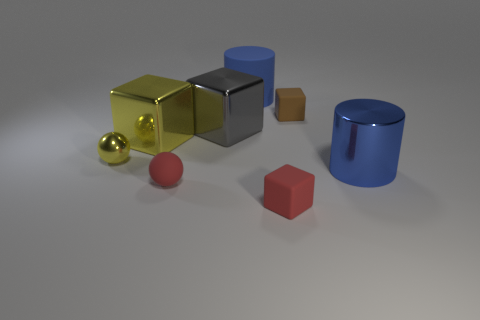Does the large cylinder in front of the small brown cube have the same material as the large blue thing that is behind the tiny brown object?
Your response must be concise. No. There is a gray thing that is to the left of the red cube; is its size the same as the rubber cylinder?
Your answer should be very brief. Yes. Do the rubber ball and the small rubber cube in front of the yellow sphere have the same color?
Your answer should be very brief. Yes. There is a metal thing that is the same color as the tiny metal ball; what shape is it?
Make the answer very short. Cube. There is a small yellow shiny thing; what shape is it?
Keep it short and to the point. Sphere. Is the big shiny cylinder the same color as the large rubber cylinder?
Provide a succinct answer. Yes. What number of objects are either big objects on the right side of the big gray object or red blocks?
Your answer should be very brief. 3. The blue cylinder that is made of the same material as the tiny brown thing is what size?
Ensure brevity in your answer.  Large. Are there more blue cylinders to the left of the blue shiny cylinder than tiny blue metal cylinders?
Offer a terse response. Yes. There is a gray object; does it have the same shape as the big yellow metal object that is on the left side of the big blue rubber object?
Your answer should be compact. Yes. 